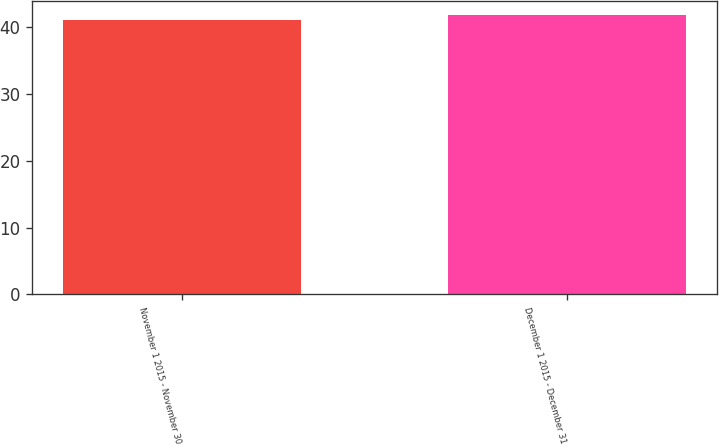<chart> <loc_0><loc_0><loc_500><loc_500><bar_chart><fcel>November 1 2015 - November 30<fcel>December 1 2015 - December 31<nl><fcel>41.05<fcel>41.8<nl></chart> 